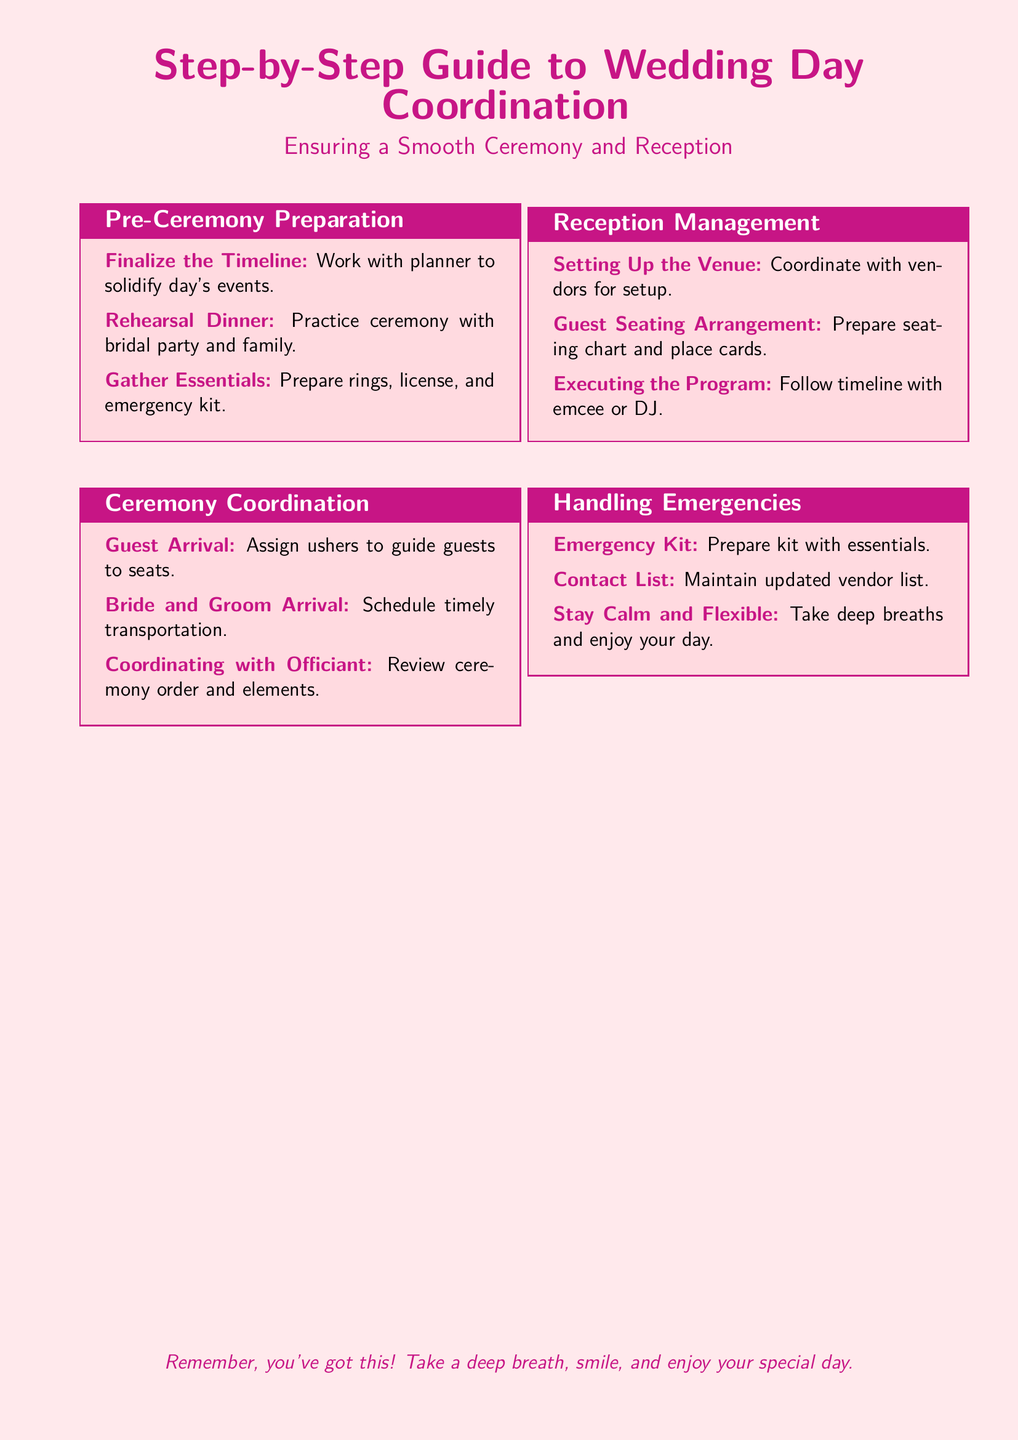what is the title of the document? The title of the document is presented prominently at the top, summarizing its purpose.
Answer: Step-by-Step Guide to Wedding Day Coordination how many sections are in the document? The document has four main sections outlined for wedding day coordination.
Answer: 4 what should you prepare in the emergency kit? The document advises to prepare the emergency kit with several essential items for unexpected situations.
Answer: essentials who should assign ushers to guide guests? The document suggests that it is important to have assigned personnel manage the seating arrangement.
Answer: ushers what is the purpose of the rehearsal dinner? The rehearsal dinner's purpose is to help the bridal party and family practice for the ceremony.
Answer: practice ceremony what should you coordinate with vendors during reception management? In reception management, setting up the venue involves collaboration with various service providers.
Answer: setup what should you maintain an updated list of? The document indicates that it is critical to keep track of essential contacts during the wedding day.
Answer: vendor list what is the advice given for handling emergencies? The document includes a piece of advice emphasizing the importance of maintaining composure during incidents.
Answer: Stay Calm and Flexible 